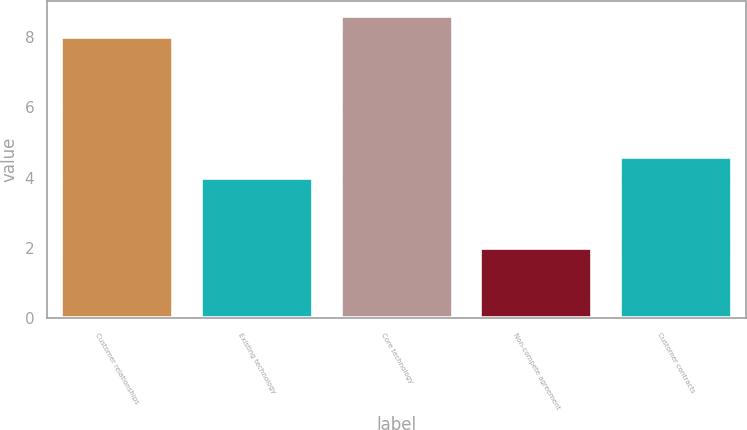Convert chart. <chart><loc_0><loc_0><loc_500><loc_500><bar_chart><fcel>Customer relationships<fcel>Existing technology<fcel>Core technology<fcel>Non-compete agreement<fcel>Customer contracts<nl><fcel>8<fcel>4<fcel>8.6<fcel>2<fcel>4.6<nl></chart> 